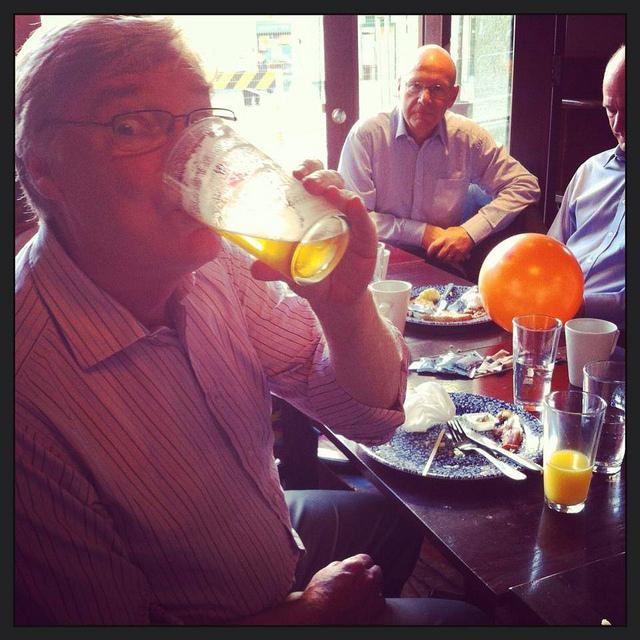What drug is this man ingesting? alcohol 